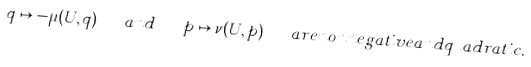Convert formula to latex. <formula><loc_0><loc_0><loc_500><loc_500>q \mapsto - \mu ( U , q ) \quad a n d \quad p \mapsto \nu ( U , p ) \quad a r e n o n n e g a t i v e a n d q u a d r a t i c .</formula> 